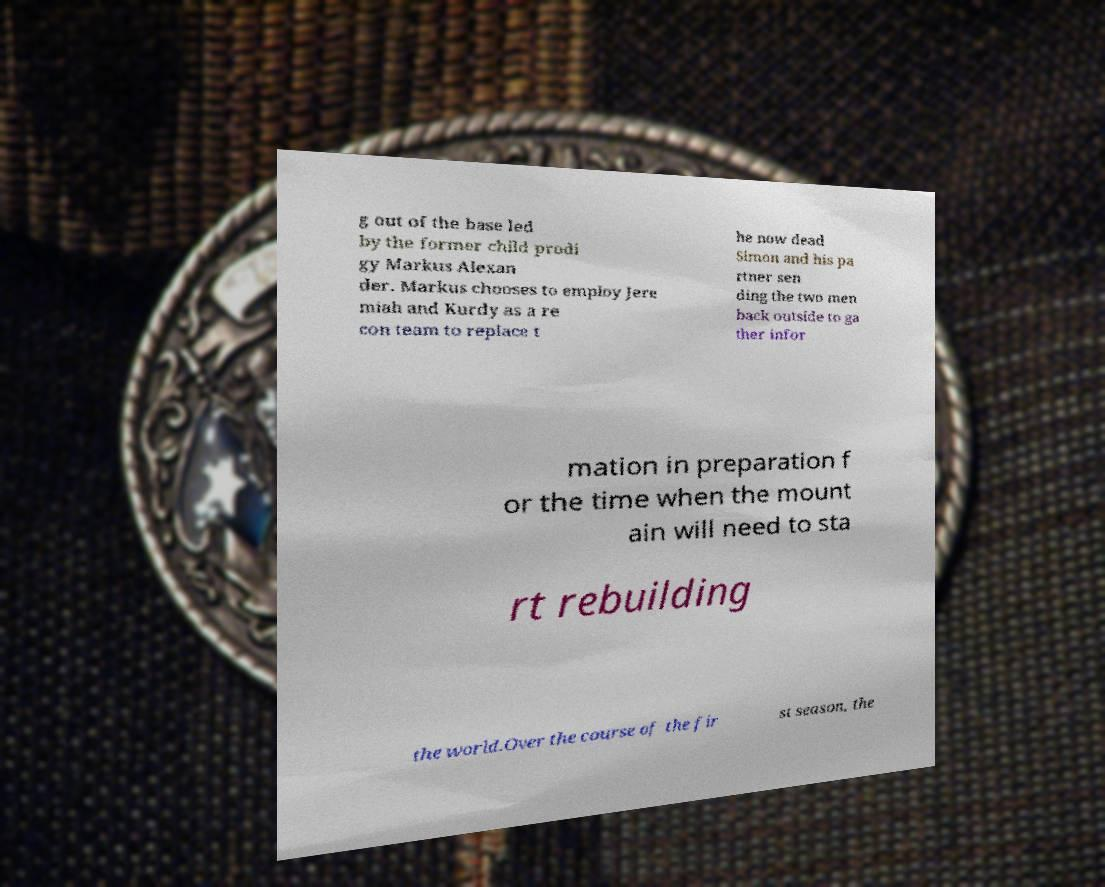I need the written content from this picture converted into text. Can you do that? g out of the base led by the former child prodi gy Markus Alexan der. Markus chooses to employ Jere miah and Kurdy as a re con team to replace t he now dead Simon and his pa rtner sen ding the two men back outside to ga ther infor mation in preparation f or the time when the mount ain will need to sta rt rebuilding the world.Over the course of the fir st season, the 